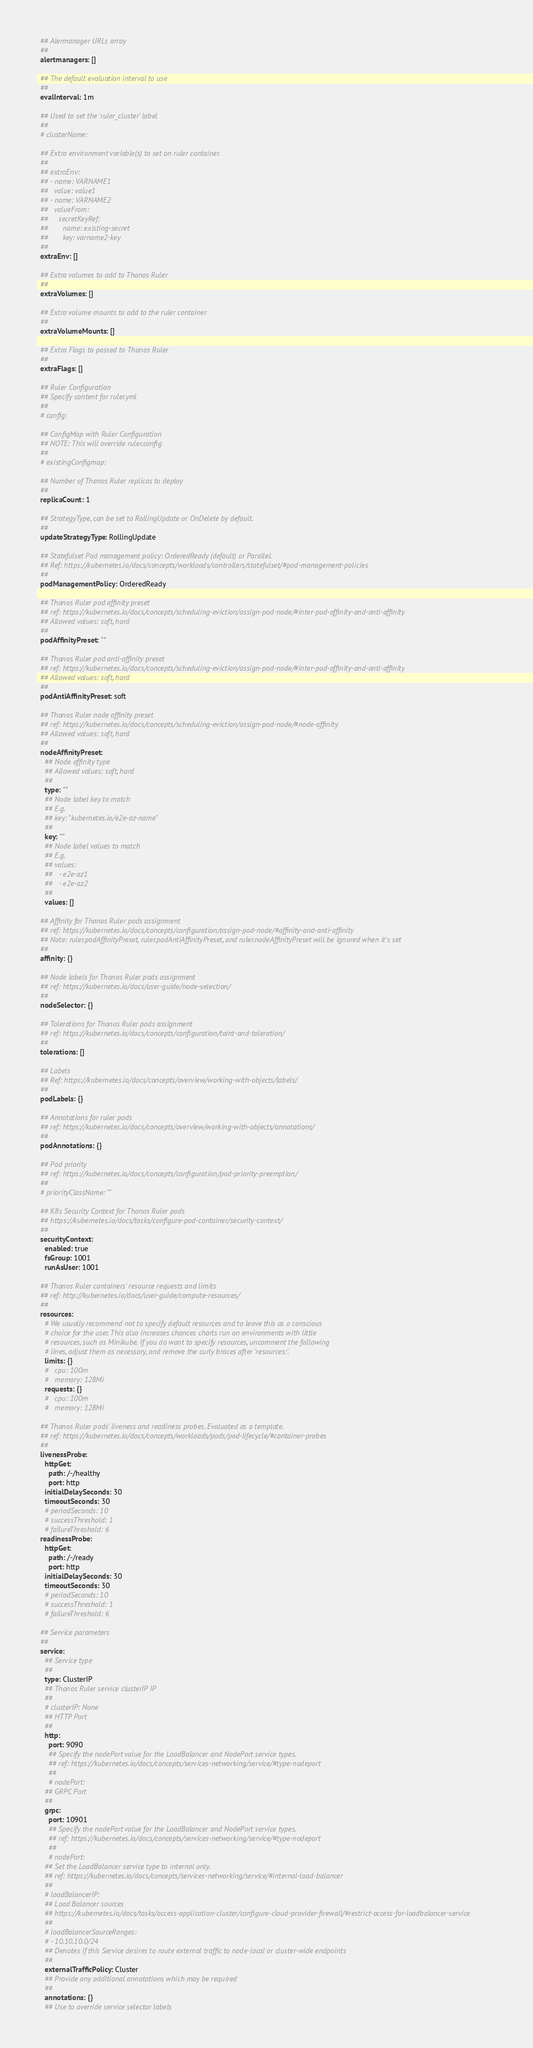Convert code to text. <code><loc_0><loc_0><loc_500><loc_500><_YAML_>
  ## Alermanager URLs array
  ##
  alertmanagers: []

  ## The default evaluation interval to use
  ##
  evalInterval: 1m

  ## Used to set the 'ruler_cluster' label
  ##
  # clusterName:

  ## Extra environment variable(s) to set on ruler container.
  ##
  ## extraEnv:
  ## - name: VARNAME1
  ##   value: value1
  ## - name: VARNAME2
  ##   valueFrom:
  ##     secretKeyRef:
  ##       name: existing-secret
  ##       key: varname2-key
  ##
  extraEnv: []

  ## Extra volumes to add to Thanos Ruler
  ##
  extraVolumes: []

  ## Extra volume mounts to add to the ruler container
  ##
  extraVolumeMounts: []

  ## Extra Flags to passed to Thanos Ruler
  ##
  extraFlags: []

  ## Ruler Configuration
  ## Specify content for ruler.yml
  ##
  # config:

  ## ConfigMap with Ruler Configuration
  ## NOTE: This will override ruler.config
  ##
  # existingConfigmap:

  ## Number of Thanos Ruler replicas to deploy
  ##
  replicaCount: 1

  ## StrategyType, can be set to RollingUpdate or OnDelete by default.
  ##
  updateStrategyType: RollingUpdate

  ## Statefulset Pod management policy: OrderedReady (default) or Parallel.
  ## Ref: https://kubernetes.io/docs/concepts/workloads/controllers/statefulset/#pod-management-policies
  ##
  podManagementPolicy: OrderedReady

  ## Thanos Ruler pod affinity preset
  ## ref: https://kubernetes.io/docs/concepts/scheduling-eviction/assign-pod-node/#inter-pod-affinity-and-anti-affinity
  ## Allowed values: soft, hard
  ##
  podAffinityPreset: ""

  ## Thanos Ruler pod anti-affinity preset
  ## ref: https://kubernetes.io/docs/concepts/scheduling-eviction/assign-pod-node/#inter-pod-affinity-and-anti-affinity
  ## Allowed values: soft, hard
  ##
  podAntiAffinityPreset: soft

  ## Thanos Ruler node affinity preset
  ## ref: https://kubernetes.io/docs/concepts/scheduling-eviction/assign-pod-node/#node-affinity
  ## Allowed values: soft, hard
  ##
  nodeAffinityPreset:
    ## Node affinity type
    ## Allowed values: soft, hard
    ##
    type: ""
    ## Node label key to match
    ## E.g.
    ## key: "kubernetes.io/e2e-az-name"
    ##
    key: ""
    ## Node label values to match
    ## E.g.
    ## values:
    ##   - e2e-az1
    ##   - e2e-az2
    ##
    values: []

  ## Affinity for Thanos Ruler pods assignment
  ## ref: https://kubernetes.io/docs/concepts/configuration/assign-pod-node/#affinity-and-anti-affinity
  ## Note: ruler.podAffinityPreset, ruler.podAntiAffinityPreset, and ruler.nodeAffinityPreset will be ignored when it's set
  ##
  affinity: {}

  ## Node labels for Thanos Ruler pods assignment
  ## ref: https://kubernetes.io/docs/user-guide/node-selection/
  ##
  nodeSelector: {}

  ## Tolerations for Thanos Ruler pods assignment
  ## ref: https://kubernetes.io/docs/concepts/configuration/taint-and-toleration/
  ##
  tolerations: []

  ## Labels
  ## Ref: https://kubernetes.io/docs/concepts/overview/working-with-objects/labels/
  ##
  podLabels: {}

  ## Annotations for ruler pods
  ## ref: https://kubernetes.io/docs/concepts/overview/working-with-objects/annotations/
  ##
  podAnnotations: {}

  ## Pod priority
  ## ref: https://kubernetes.io/docs/concepts/configuration/pod-priority-preemption/
  ##
  # priorityClassName: ""

  ## K8s Security Context for Thanos Ruler pods
  ## https://kubernetes.io/docs/tasks/configure-pod-container/security-context/
  ##
  securityContext:
    enabled: true
    fsGroup: 1001
    runAsUser: 1001

  ## Thanos Ruler containers' resource requests and limits
  ## ref: http://kubernetes.io/docs/user-guide/compute-resources/
  ##
  resources:
    # We usually recommend not to specify default resources and to leave this as a conscious
    # choice for the user. This also increases chances charts run on environments with little
    # resources, such as Minikube. If you do want to specify resources, uncomment the following
    # lines, adjust them as necessary, and remove the curly braces after 'resources:'.
    limits: {}
    #   cpu: 100m
    #   memory: 128Mi
    requests: {}
    #   cpu: 100m
    #   memory: 128Mi

  ## Thanos Ruler pods' liveness and readiness probes. Evaluated as a template.
  ## ref: https://kubernetes.io/docs/concepts/workloads/pods/pod-lifecycle/#container-probes
  ##
  livenessProbe:
    httpGet:
      path: /-/healthy
      port: http
    initialDelaySeconds: 30
    timeoutSeconds: 30
    # periodSeconds: 10
    # successThreshold: 1
    # failureThreshold: 6
  readinessProbe:
    httpGet:
      path: /-/ready
      port: http
    initialDelaySeconds: 30
    timeoutSeconds: 30
    # periodSeconds: 10
    # successThreshold: 1
    # failureThreshold: 6

  ## Service parameters
  ##
  service:
    ## Service type
    ##
    type: ClusterIP
    ## Thanos Ruler service clusterIP IP
    ##
    # clusterIP: None
    ## HTTP Port
    ##
    http:
      port: 9090
      ## Specify the nodePort value for the LoadBalancer and NodePort service types.
      ## ref: https://kubernetes.io/docs/concepts/services-networking/service/#type-nodeport
      ##
      # nodePort:
    ## GRPC Port
    ##
    grpc:
      port: 10901
      ## Specify the nodePort value for the LoadBalancer and NodePort service types.
      ## ref: https://kubernetes.io/docs/concepts/services-networking/service/#type-nodeport
      ##
      # nodePort:
    ## Set the LoadBalancer service type to internal only.
    ## ref: https://kubernetes.io/docs/concepts/services-networking/service/#internal-load-balancer
    ##
    # loadBalancerIP:
    ## Load Balancer sources
    ## https://kubernetes.io/docs/tasks/access-application-cluster/configure-cloud-provider-firewall/#restrict-access-for-loadbalancer-service
    ##
    # loadBalancerSourceRanges:
    # - 10.10.10.0/24
    ## Denotes if this Service desires to route external traffic to node-local or cluster-wide endpoints
    ##
    externalTrafficPolicy: Cluster
    ## Provide any additional annotations which may be required
    ##
    annotations: {}
    ## Use to override service selector labels</code> 